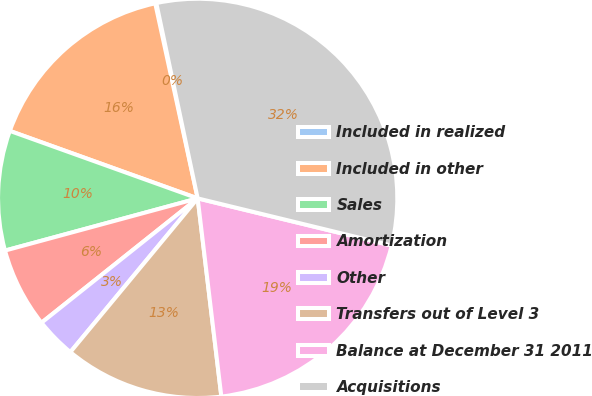<chart> <loc_0><loc_0><loc_500><loc_500><pie_chart><fcel>Included in realized<fcel>Included in other<fcel>Sales<fcel>Amortization<fcel>Other<fcel>Transfers out of Level 3<fcel>Balance at December 31 2011<fcel>Acquisitions<nl><fcel>0.09%<fcel>16.1%<fcel>9.7%<fcel>6.49%<fcel>3.29%<fcel>12.9%<fcel>19.31%<fcel>32.12%<nl></chart> 